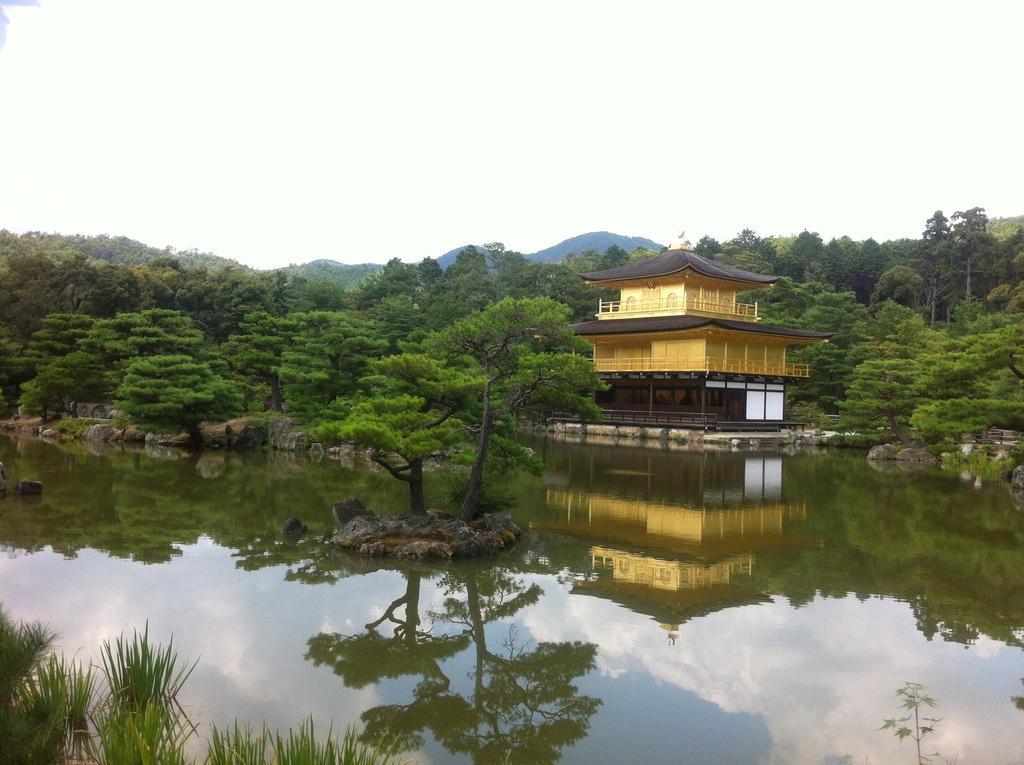Please provide a concise description of this image. In this image in the foreground there is a canal, in the bottom left there is grass, on the canal there is a tree, stones visible , in the middle there are trees, buildings visible, at the top there is the sky. 